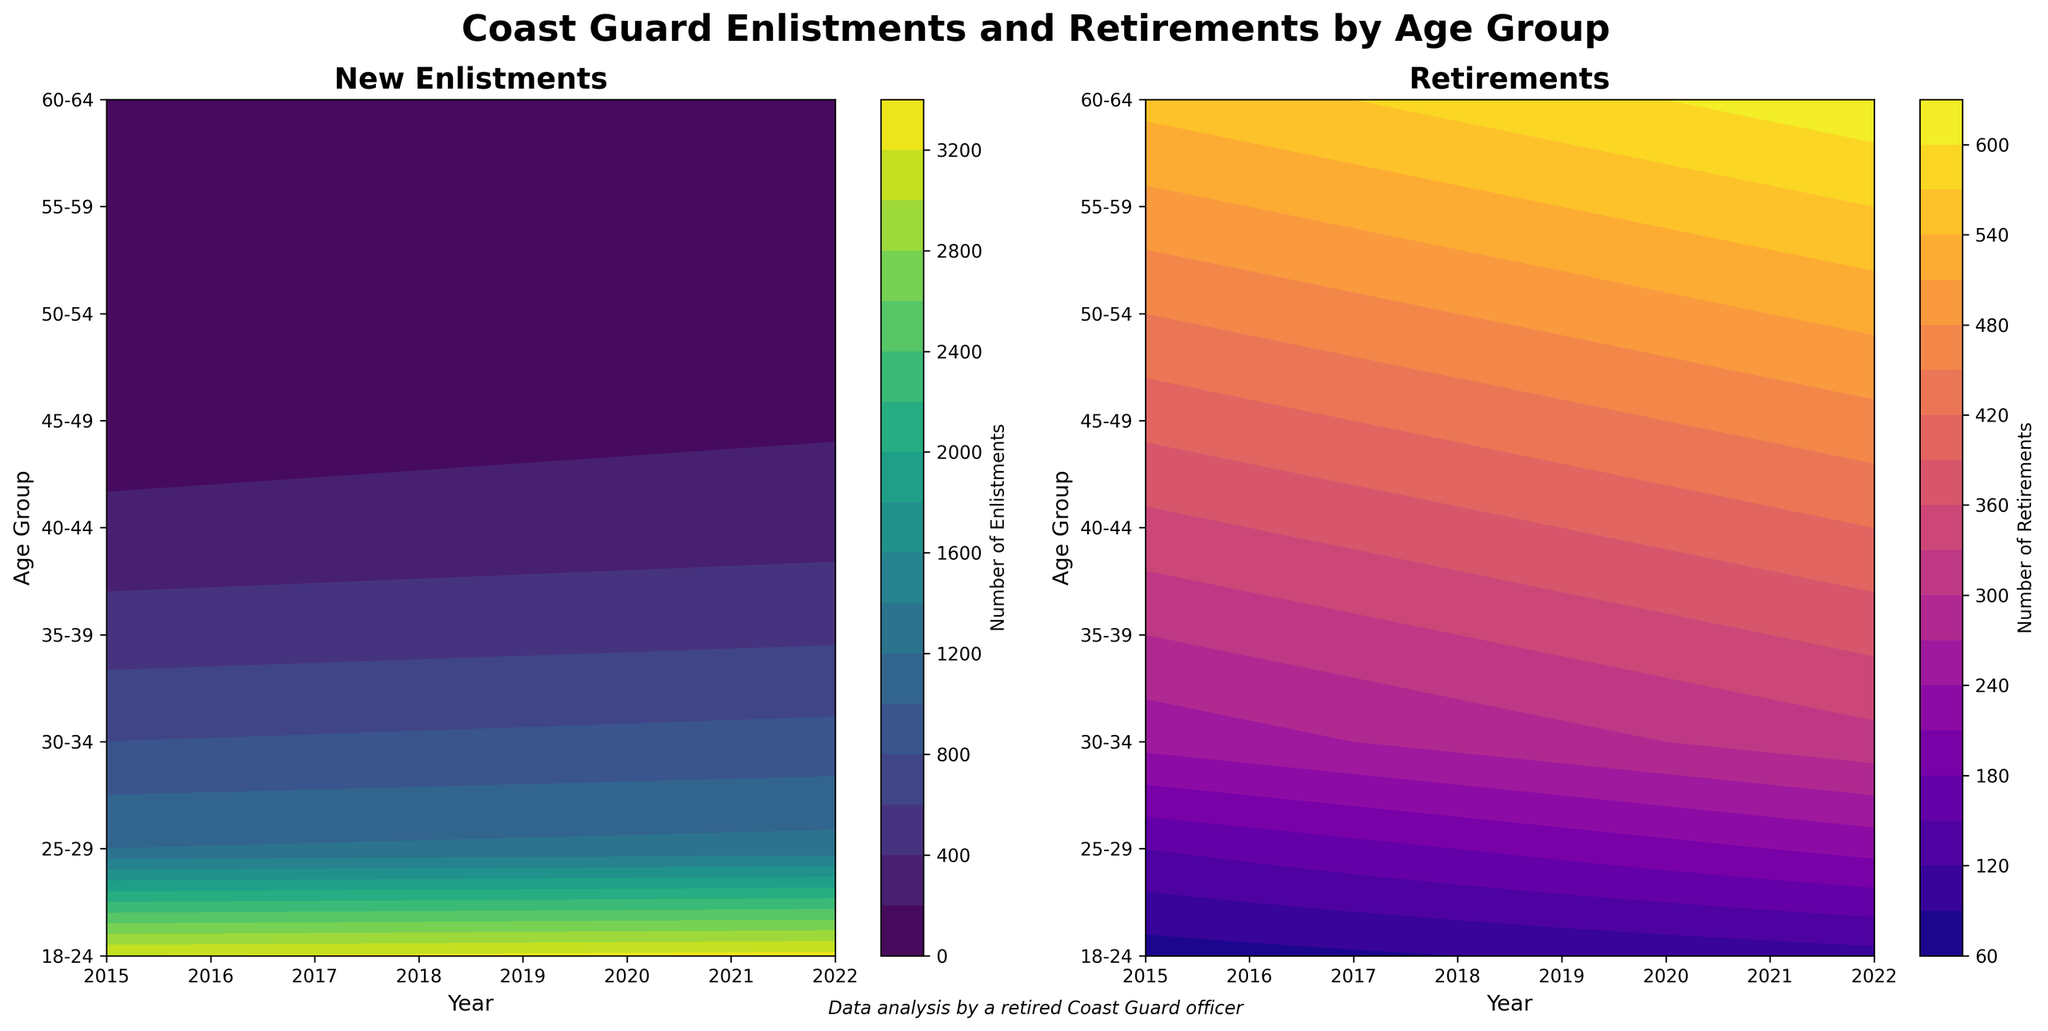What is the title of the subplot on the left? The title of the subplot can be directly read from the figure. It is displayed at the top of the left subplot.
Answer: New Enlistments Which age group has the highest number of retirements in 2021? By examining the right contour plot, find the highest value contour for the year 2021 and check the corresponding age group. The color bar can help determine the highest values.
Answer: 60-64 How does the number of new enlistments for the 18-24 age group change from 2015 to 2022? Look at the left contour plot and find the contour line for the 18-24 age group across the years 2015 to 2022. The change can be seen by following the color gradient or numeric labels.
Answer: Increases Which year has the largest disparity between new enlistments and retirements for the 30-34 age group? Check both left and right contour plots for the 30-34 age group. Determine the numeric differences between enlistments and retirements for each year and identify the year with the largest gap.
Answer: 2022 What color scheme is used for the contour plot of retirements? Identify the color scheme by examining the legend and the overall color appearance of the contour plot on the right subplot.
Answer: Plasma In which age group and year do the enlistments and retirements appear to cross each other or become equal? Look for nearly identical colors in both contour plots (left for enlistments and right for retirements) and identify the corresponding age group and year where values are very close or equal.
Answer: 55-59 in 2021 Compare the trend of retirements for the 45-49 age group over the years. Is it increasing, decreasing, or stable? By examining the right contour plot, observe how the 45-49 age group's color values change from 2015 to 2022. Note whether the values become increasingly darker (or higher according to the color legend).
Answer: Increasing 